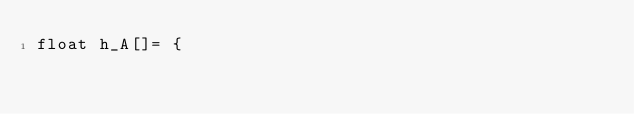<code> <loc_0><loc_0><loc_500><loc_500><_Cuda_>float h_A[]= {</code> 